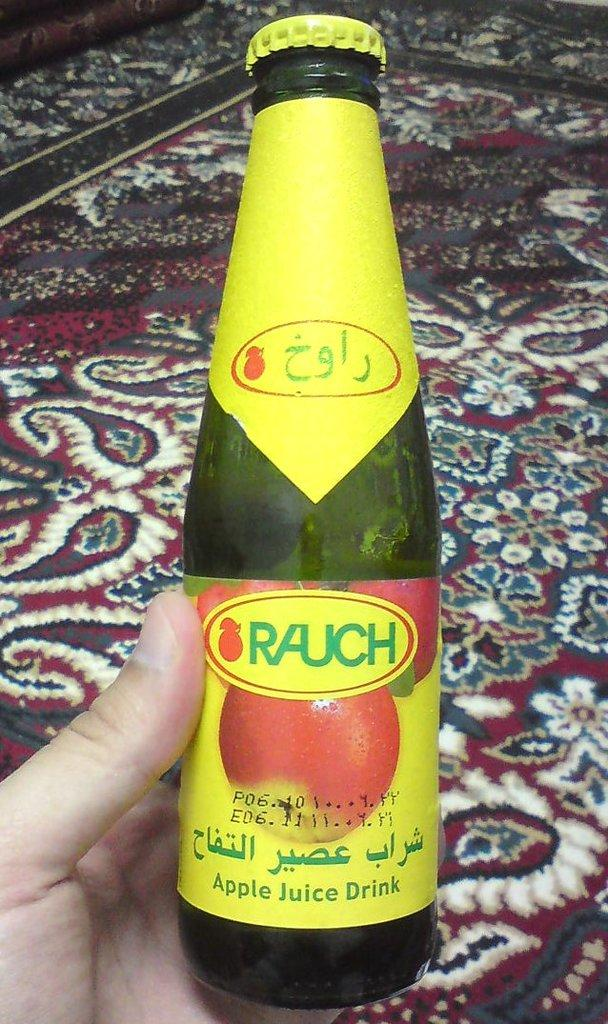Provide a one-sentence caption for the provided image. a person holding onto some yellow bottle in their hand with Rauch on it. 